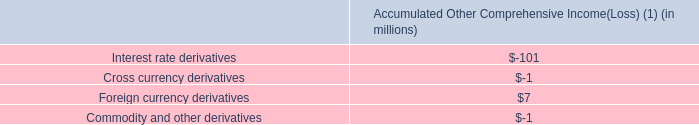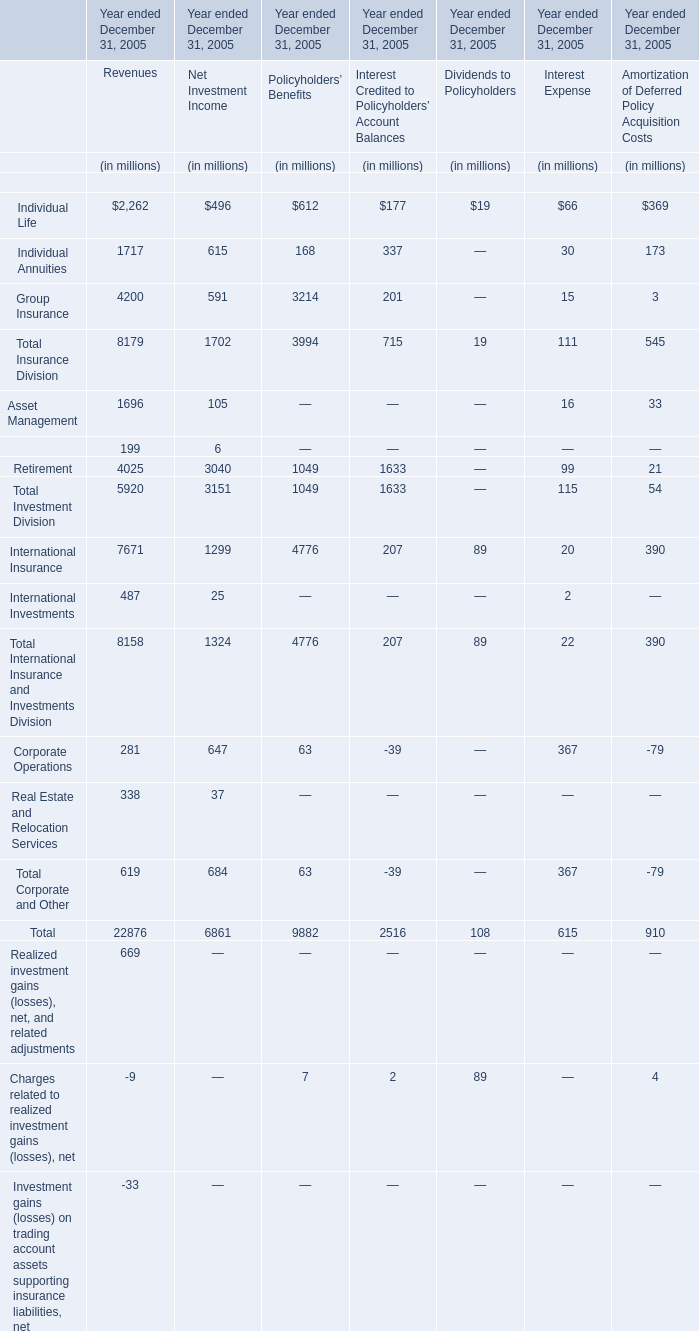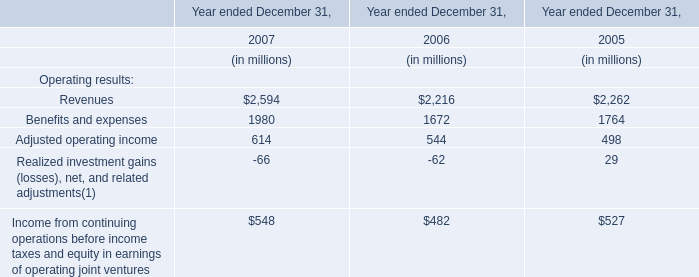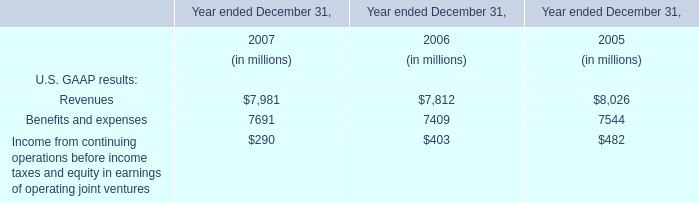Does the value of Individual Life forNet Investment Income greater than that in Revenues 
Answer: no. 